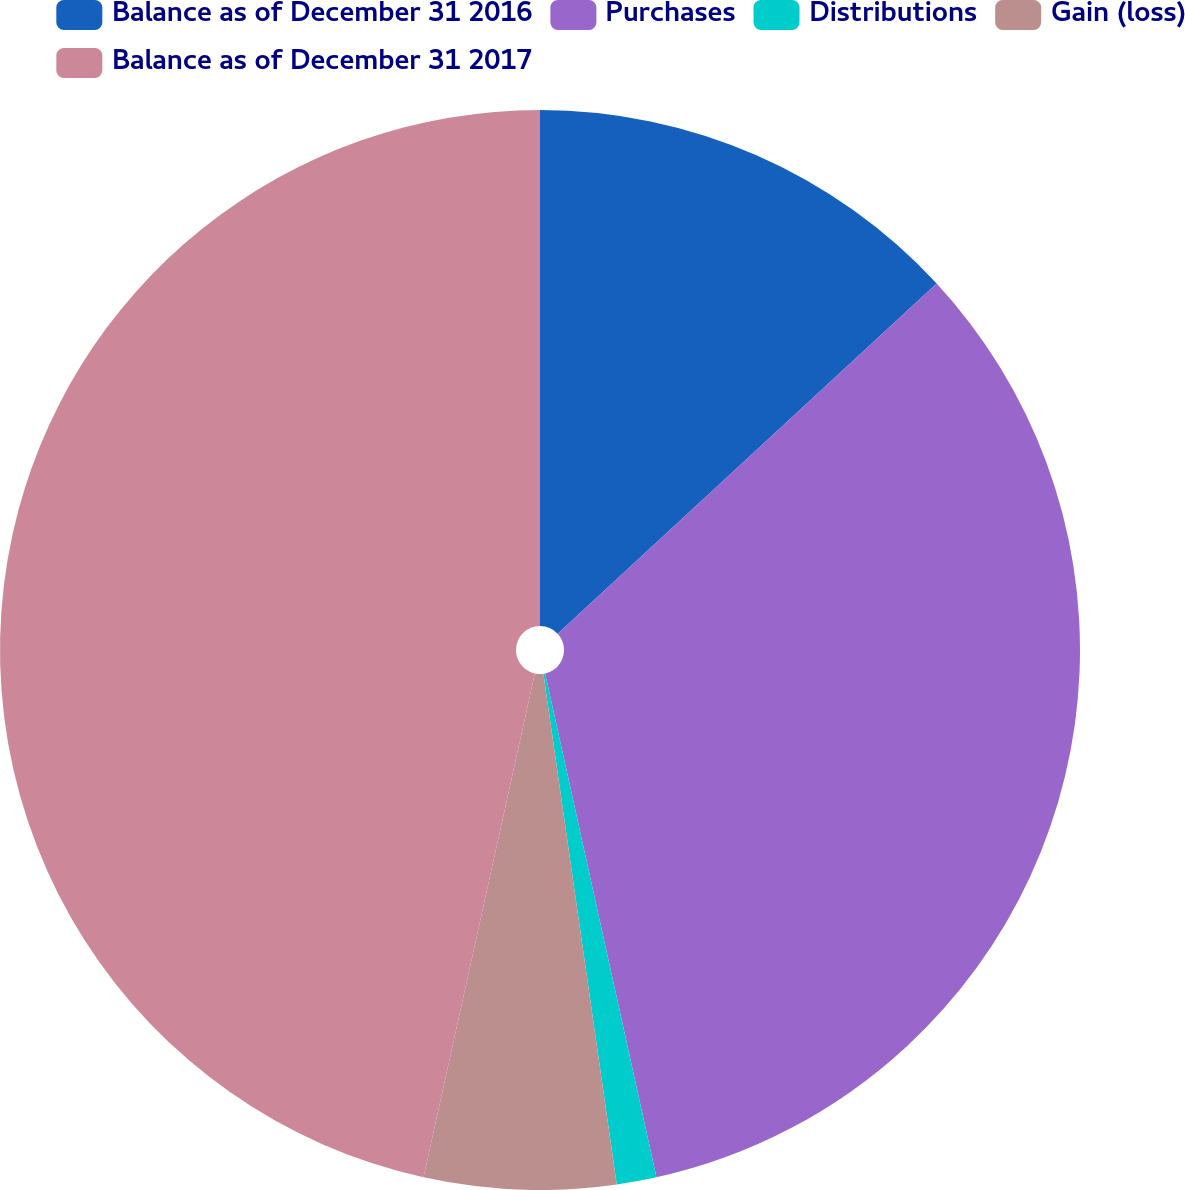<chart> <loc_0><loc_0><loc_500><loc_500><pie_chart><fcel>Balance as of December 31 2016<fcel>Purchases<fcel>Distributions<fcel>Gain (loss)<fcel>Balance as of December 31 2017<nl><fcel>13.13%<fcel>33.41%<fcel>1.19%<fcel>5.73%<fcel>46.54%<nl></chart> 